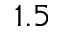Convert formula to latex. <formula><loc_0><loc_0><loc_500><loc_500>1 . 5</formula> 